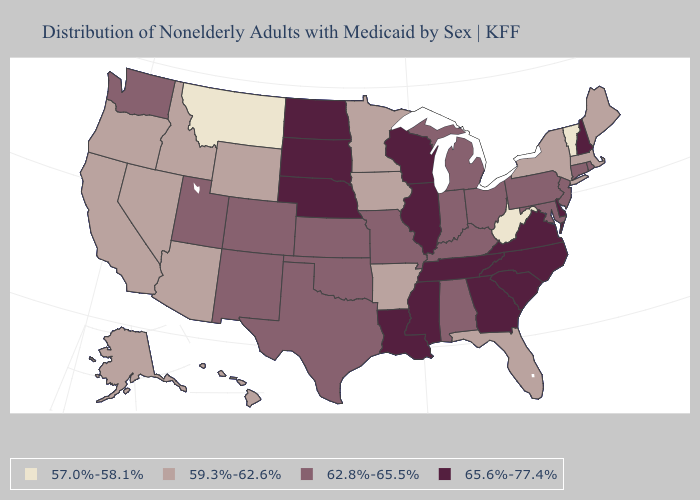What is the value of Massachusetts?
Keep it brief. 59.3%-62.6%. Among the states that border North Dakota , does South Dakota have the lowest value?
Write a very short answer. No. What is the highest value in the USA?
Keep it brief. 65.6%-77.4%. What is the value of Florida?
Quick response, please. 59.3%-62.6%. Name the states that have a value in the range 65.6%-77.4%?
Be succinct. Delaware, Georgia, Illinois, Louisiana, Mississippi, Nebraska, New Hampshire, North Carolina, North Dakota, South Carolina, South Dakota, Tennessee, Virginia, Wisconsin. What is the highest value in states that border Colorado?
Give a very brief answer. 65.6%-77.4%. Which states have the lowest value in the West?
Answer briefly. Montana. What is the lowest value in states that border Alabama?
Write a very short answer. 59.3%-62.6%. Among the states that border California , which have the lowest value?
Quick response, please. Arizona, Nevada, Oregon. Does the map have missing data?
Answer briefly. No. How many symbols are there in the legend?
Concise answer only. 4. What is the value of Pennsylvania?
Keep it brief. 62.8%-65.5%. Among the states that border Indiana , does Ohio have the lowest value?
Give a very brief answer. Yes. Which states have the lowest value in the West?
Short answer required. Montana. What is the highest value in the USA?
Give a very brief answer. 65.6%-77.4%. 